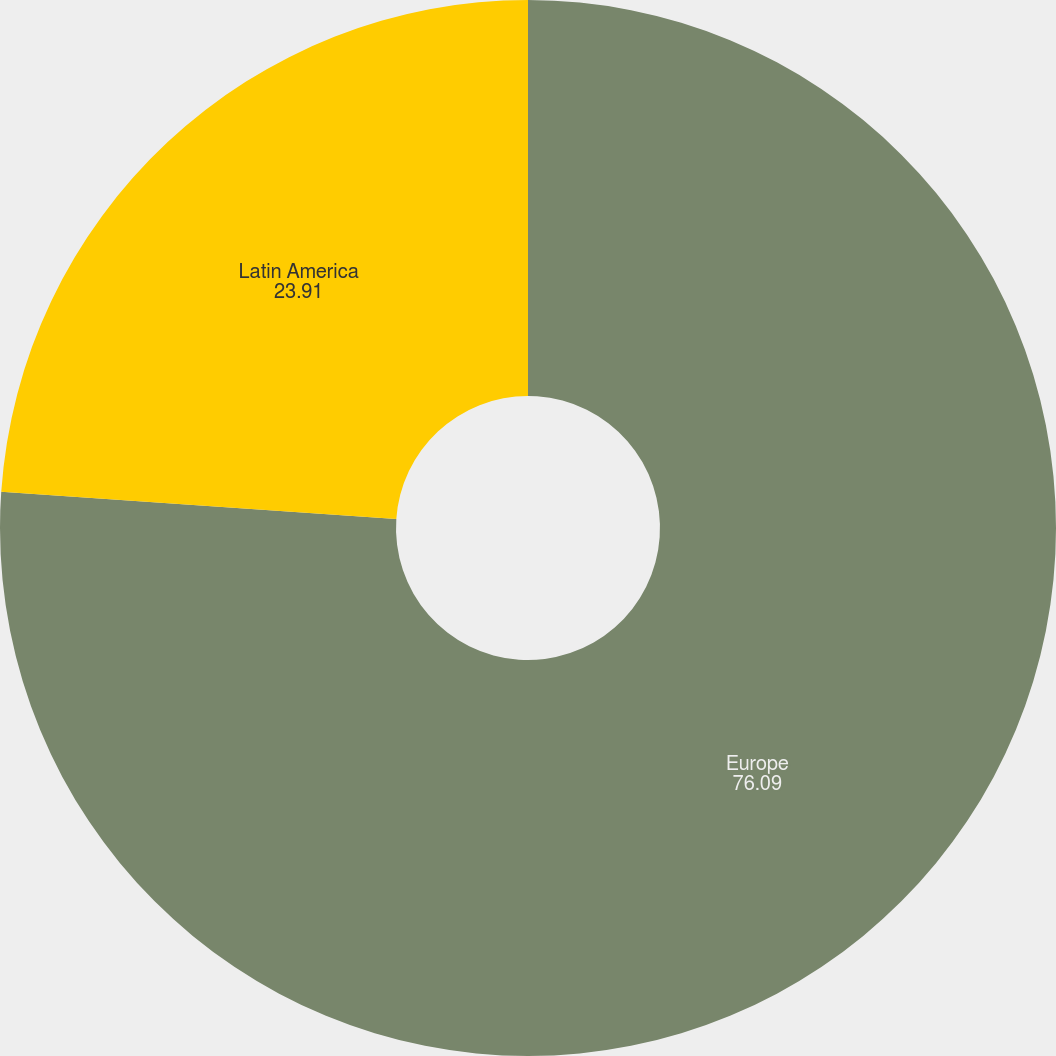<chart> <loc_0><loc_0><loc_500><loc_500><pie_chart><fcel>Europe<fcel>Latin America<nl><fcel>76.09%<fcel>23.91%<nl></chart> 